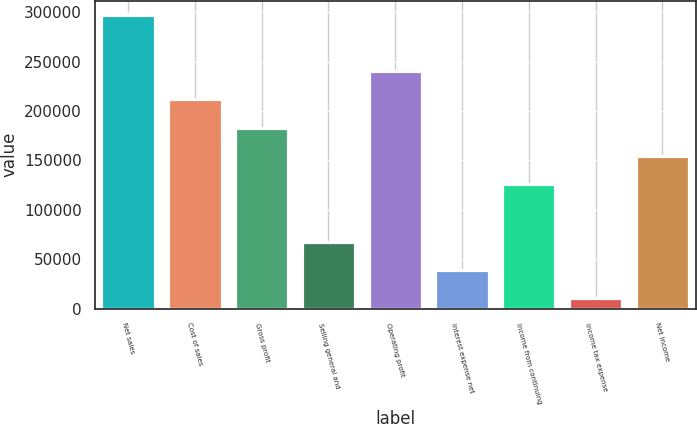Convert chart. <chart><loc_0><loc_0><loc_500><loc_500><bar_chart><fcel>Net sales<fcel>Cost of sales<fcel>Gross profit<fcel>Selling general and<fcel>Operating profit<fcel>Interest expense net<fcel>Income from continuing<fcel>Income tax expense<fcel>Net income<nl><fcel>296650<fcel>211688<fcel>183097<fcel>67926.8<fcel>240278<fcel>39336.4<fcel>125916<fcel>10746<fcel>154507<nl></chart> 